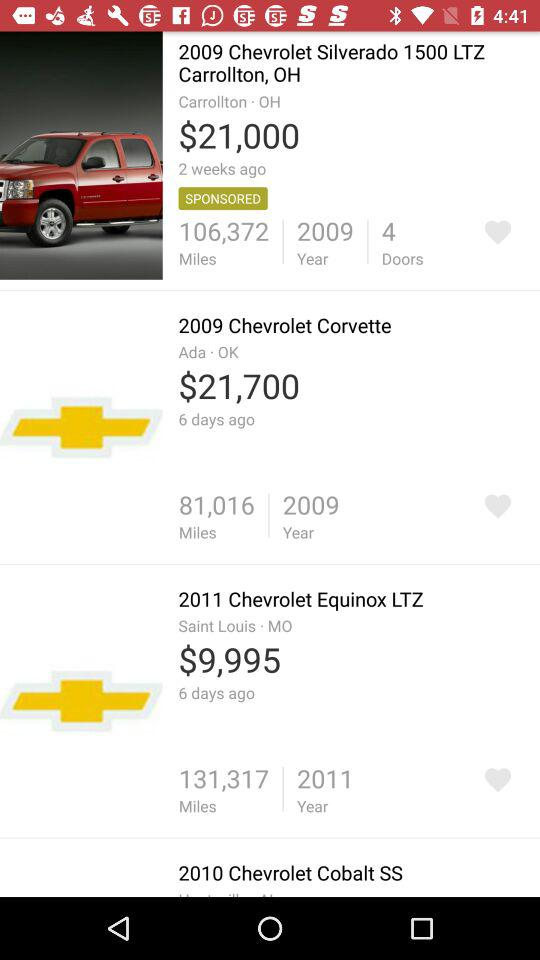In which car's specifications is the number of doors mentioned? The number of doors is mentioned in the specifications of the 2009 Chevrolet Silverado 1500 LTZ. 